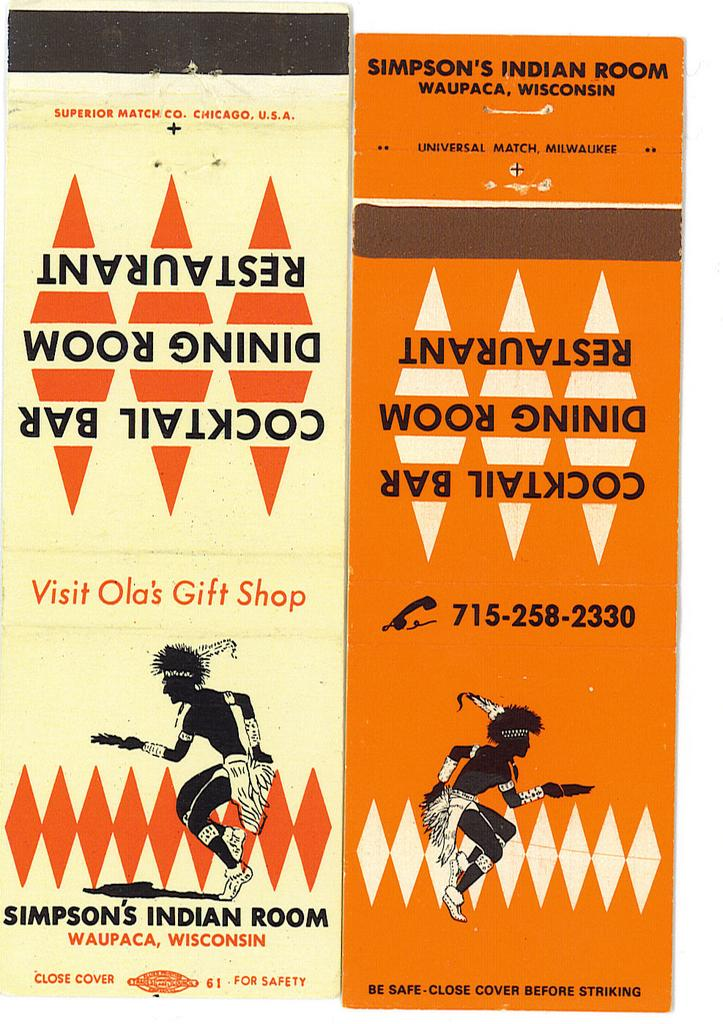What can be seen on the walls in the image? There are posters in the image. What do the posters depict? The posters have images of two people. Are there any words on the posters? Yes, there is text on the posters. How many clovers are depicted on the posters? There are no clovers present on the posters; they depict images of two people. Is there a stove visible in the image? No, there is no stove present in the image. 